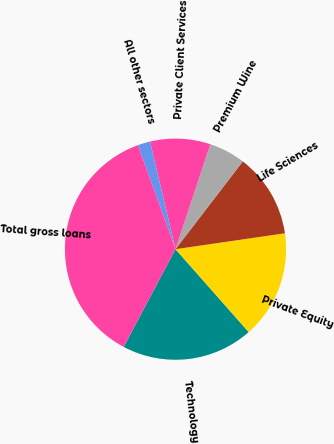<chart> <loc_0><loc_0><loc_500><loc_500><pie_chart><fcel>Technology<fcel>Private Equity<fcel>Life Sciences<fcel>Premium Wine<fcel>Private Client Services<fcel>All other sectors<fcel>Total gross loans<nl><fcel>19.27%<fcel>15.78%<fcel>12.29%<fcel>5.31%<fcel>8.8%<fcel>1.82%<fcel>36.73%<nl></chart> 